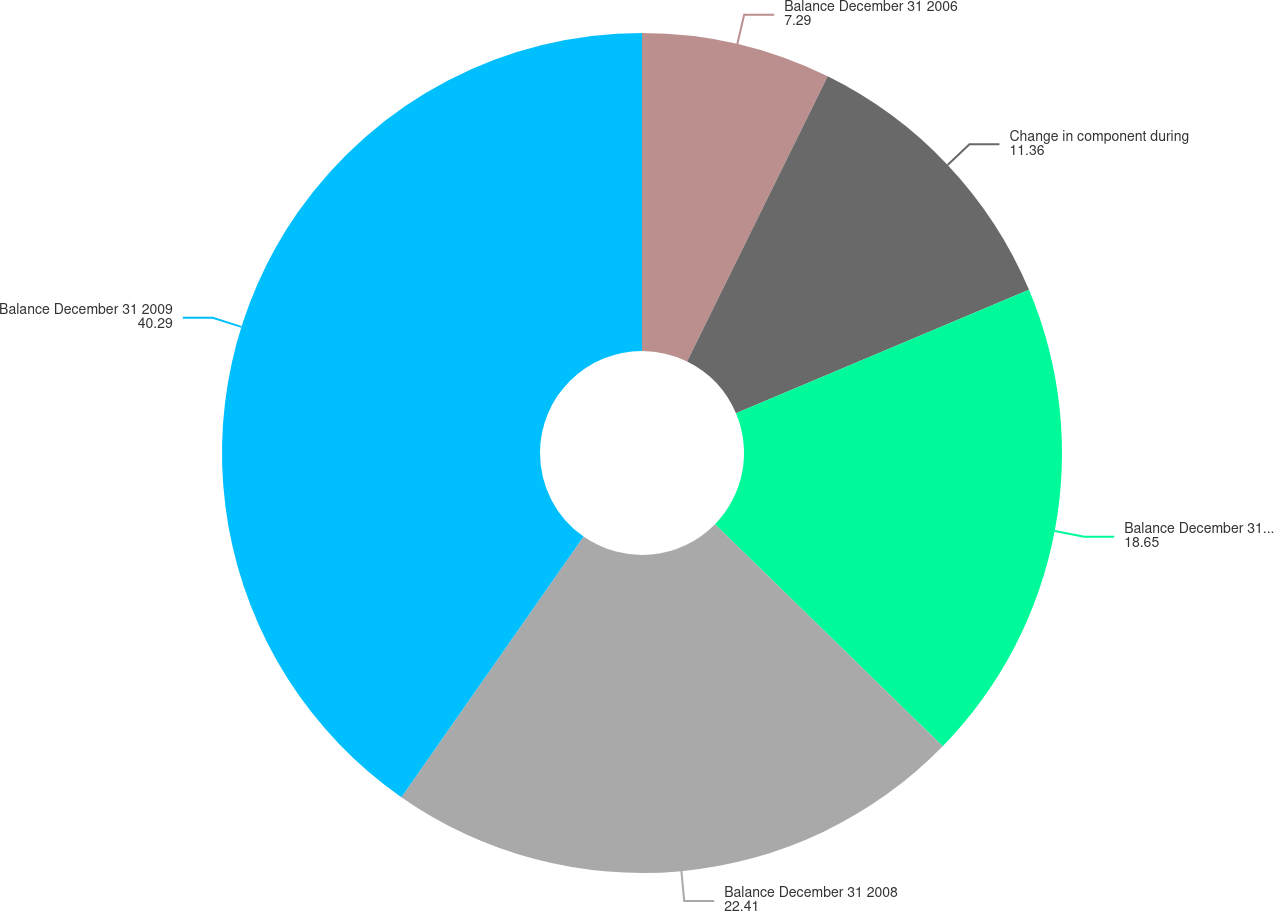<chart> <loc_0><loc_0><loc_500><loc_500><pie_chart><fcel>Balance December 31 2006<fcel>Change in component during<fcel>Balance December 31 2007<fcel>Balance December 31 2008<fcel>Balance December 31 2009<nl><fcel>7.29%<fcel>11.36%<fcel>18.65%<fcel>22.41%<fcel>40.29%<nl></chart> 